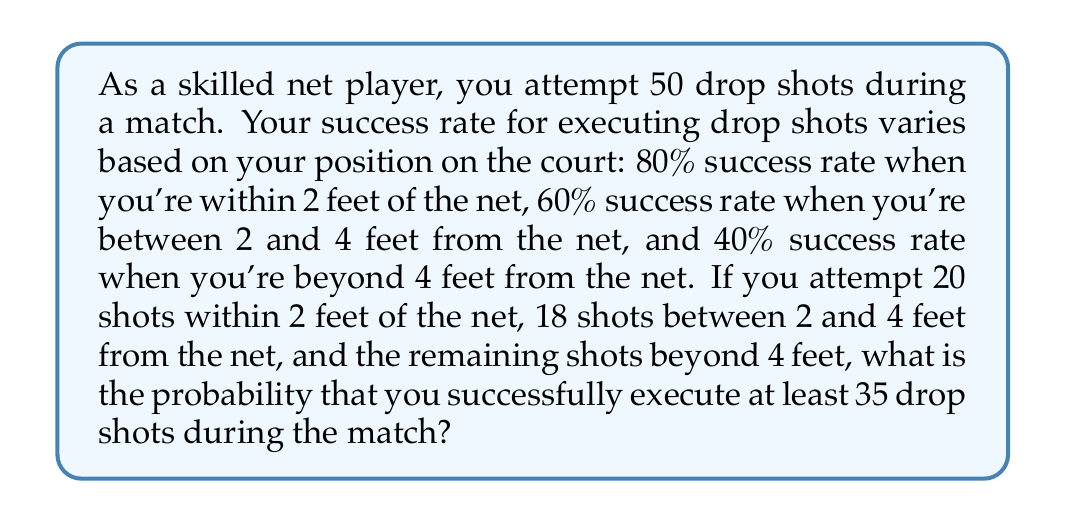Provide a solution to this math problem. Let's approach this step-by-step:

1) First, let's calculate the number of shots taken from each position:
   - Within 2 feet: 20 shots
   - Between 2 and 4 feet: 18 shots
   - Beyond 4 feet: 50 - 20 - 18 = 12 shots

2) Now, let's calculate the expected number of successful shots from each position:
   - Within 2 feet: $20 \times 0.80 = 16$
   - Between 2 and 4 feet: $18 \times 0.60 = 10.8$
   - Beyond 4 feet: $12 \times 0.40 = 4.8$

3) The total expected number of successful shots is:
   $16 + 10.8 + 4.8 = 31.6$

4) The standard deviation for each position can be calculated using the formula $\sigma = \sqrt{np(1-p)}$:
   - Within 2 feet: $\sigma_1 = \sqrt{20 \times 0.80 \times 0.20} = 1.79$
   - Between 2 and 4 feet: $\sigma_2 = \sqrt{18 \times 0.60 \times 0.40} = 2.08$
   - Beyond 4 feet: $\sigma_3 = \sqrt{12 \times 0.40 \times 0.60} = 1.70$

5) The total variance is the sum of individual variances:
   $\sigma_{total}^2 = 1.79^2 + 2.08^2 + 1.70^2 = 10.6569$

6) The total standard deviation is:
   $\sigma_{total} = \sqrt{10.6569} = 3.26$

7) We can use the normal approximation to the binomial distribution. The z-score for 35 successful shots is:
   $z = \frac{35 - 31.6}{3.26} = 1.04$

8) Using a standard normal distribution table or calculator, we find the probability of a z-score greater than 1.04 is approximately 0.1492.

Therefore, the probability of successfully executing at least 35 drop shots is about 0.1492 or 14.92%.
Answer: 0.1492 